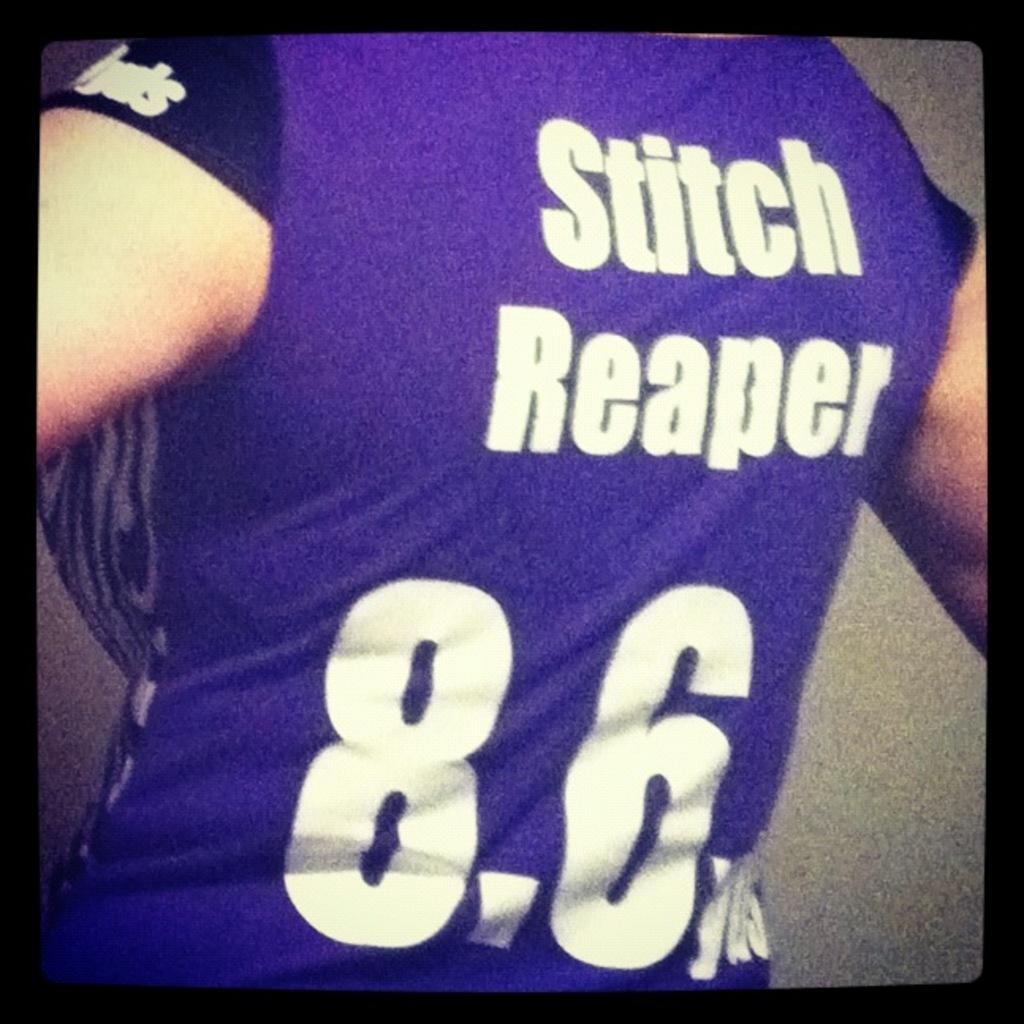<image>
Provide a brief description of the given image. A woman wearing a purple athletic shirt with the words Stitch Reaper on the back along with the numbers 8.6 and other lettering that can't be clearly seen. 